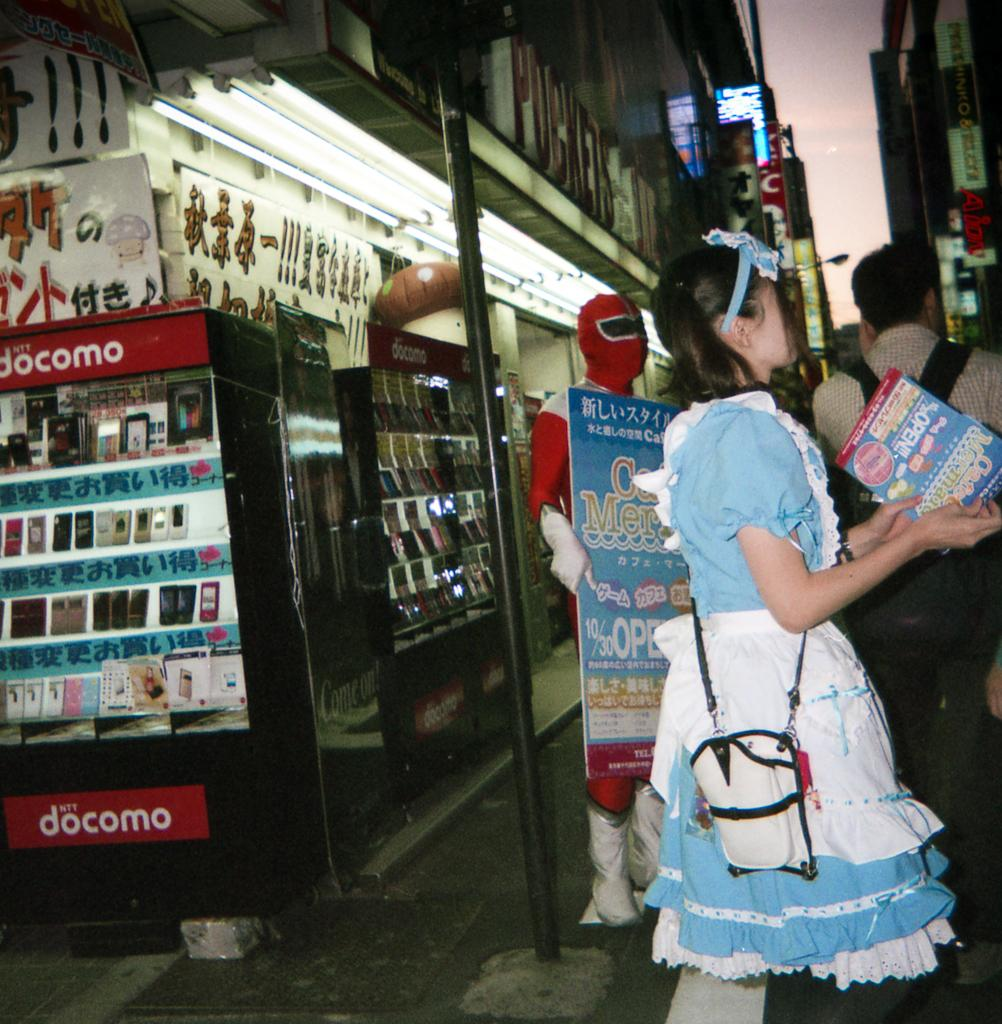<image>
Write a terse but informative summary of the picture. several people in costumes with a docomo vending machine in the background 